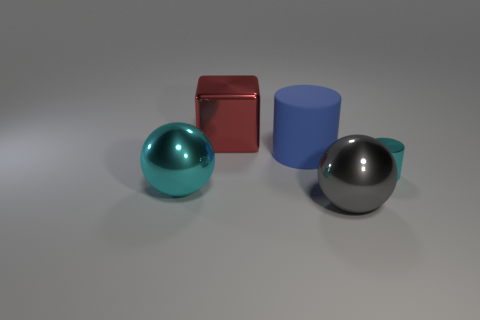What is the shape of the large thing that is the same color as the tiny metallic cylinder?
Make the answer very short. Sphere. There is another object that is the same color as the tiny thing; what size is it?
Provide a succinct answer. Large. The large object that is both in front of the large blue matte cylinder and right of the large red metallic thing is what color?
Ensure brevity in your answer.  Gray. There is a blue object; is its size the same as the cyan shiny thing to the left of the tiny cylinder?
Ensure brevity in your answer.  Yes. What is the shape of the cyan shiny object on the left side of the big blue thing?
Give a very brief answer. Sphere. Are there any other things that are the same material as the gray thing?
Make the answer very short. Yes. Is the number of large red objects in front of the big gray metallic thing greater than the number of tiny cyan rubber balls?
Make the answer very short. No. There is a cyan metal object on the right side of the cyan shiny thing that is left of the tiny metal thing; how many big red metal objects are behind it?
Provide a short and direct response. 1. There is a cyan object that is on the right side of the cyan metal ball; is its size the same as the sphere that is behind the gray metallic thing?
Give a very brief answer. No. There is a cyan thing that is behind the shiny object that is on the left side of the red object; what is its material?
Offer a terse response. Metal. 